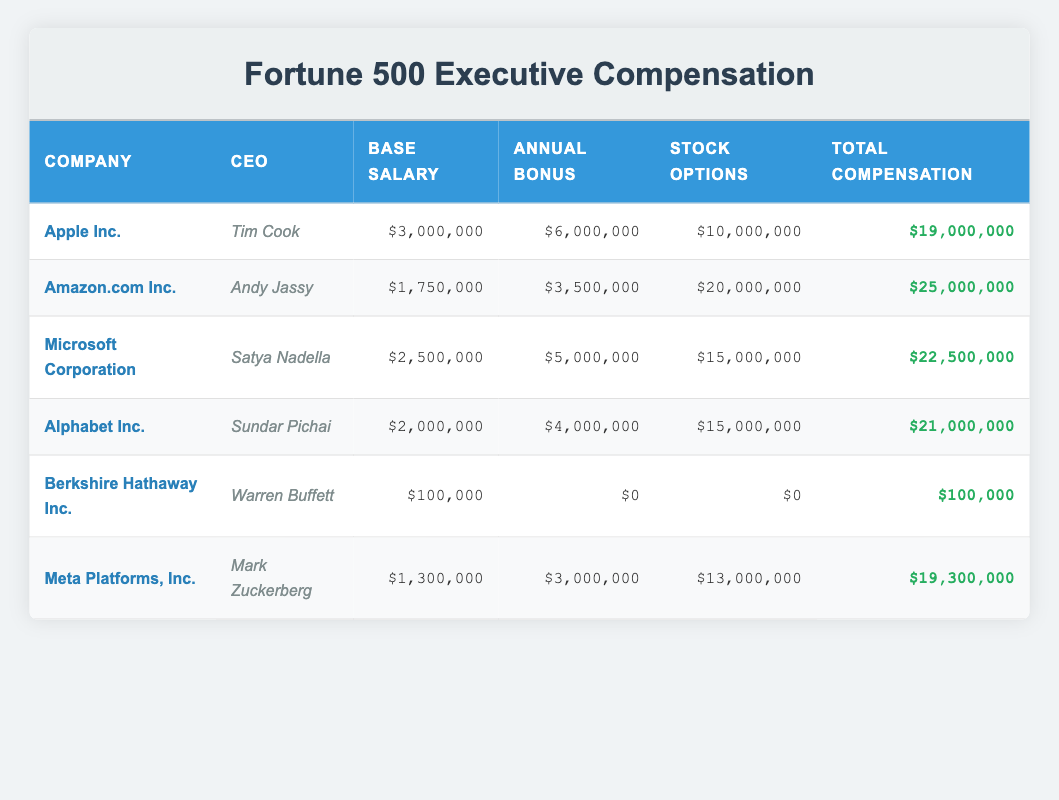What is the total compensation for Amazon.com Inc.? In the table, we look at the row for Amazon.com Inc., where the total compensation is clearly stated as 25,000,000.
Answer: 25,000,000 Who is the CEO of Microsoft Corporation? Referring to the row for Microsoft Corporation in the table, we can see that the CEO listed is Satya Nadella.
Answer: Satya Nadella What is the total compensation difference between Apple Inc. and Meta Platforms, Inc.? First, we find the total compensation for Apple Inc., which is 19,000,000, and for Meta Platforms, Inc., which is 19,300,000. The difference is 19,300,000 - 19,000,000 = 300,000.
Answer: 300,000 Does Warren Buffett receive an annual bonus? Looking at Warren Buffett's row in the table, the annual bonus is stated as 0, indicating that he does not receive an annual bonus.
Answer: No What are the average base salaries of the CEOs for the top five firms listed in the table? The base salaries for the five CEOs are 3,000,000 (Apple), 1,750,000 (Amazon), 2,500,000 (Microsoft), 2,000,000 (Alphabet), and 100,000 (Berkshire). Adding these gives us 3,000,000 + 1,750,000 + 2,500,000 + 2,000,000 + 100,000 = 9,350,000. Dividing by 5 gives an average of 1,870,000.
Answer: 1,870,000 Which company has the highest stock options, and what is the amount? By checking the stock options for each company, we find that Amazon.com Inc. has the highest stock options listed as 20,000,000.
Answer: Amazon.com Inc., 20,000,000 What is the total compensation of the CEO with the lowest compensation? Reviewing the table, Berkshire Hathaway Inc. has the lowest total compensation of 100,000.
Answer: 100,000 Is it true that Sundar Pichai has a total compensation greater than Mark Zuckerberg? Looking at the total compensation for Sundar Pichai, it is 21,000,000, and for Mark Zuckerberg it is 19,300,000. Since 21,000,000 is greater than 19,300,000, the statement is true.
Answer: Yes What is the stock options amount for the CEO of Alphabet Inc.? Checking the row for Alphabet Inc., we see that the stock options amount for Sundar Pichai is listed as 15,000,000.
Answer: 15,000,000 